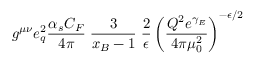Convert formula to latex. <formula><loc_0><loc_0><loc_500><loc_500>g ^ { \mu \nu } e _ { q } ^ { 2 } { \frac { \alpha _ { s } C _ { F } } { 4 \pi } } \, { \frac { 3 } { x _ { B } - 1 } } \, { \frac { 2 } { \epsilon } } \left ( { \frac { Q ^ { 2 } e ^ { \gamma _ { E } } } { 4 \pi \mu _ { 0 } ^ { 2 } } } \right ) ^ { - \epsilon / 2 }</formula> 